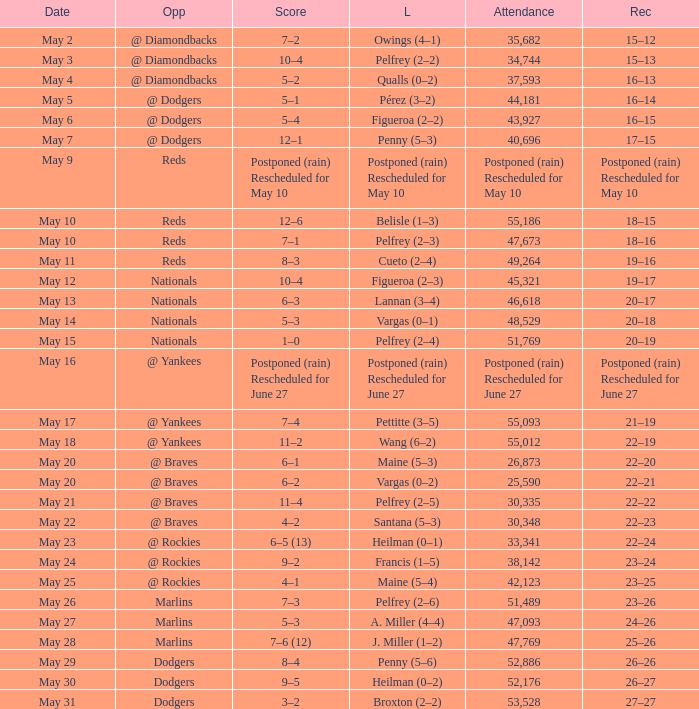Loss of postponed (rain) rescheduled for may 10 had what record? Postponed (rain) Rescheduled for May 10. 